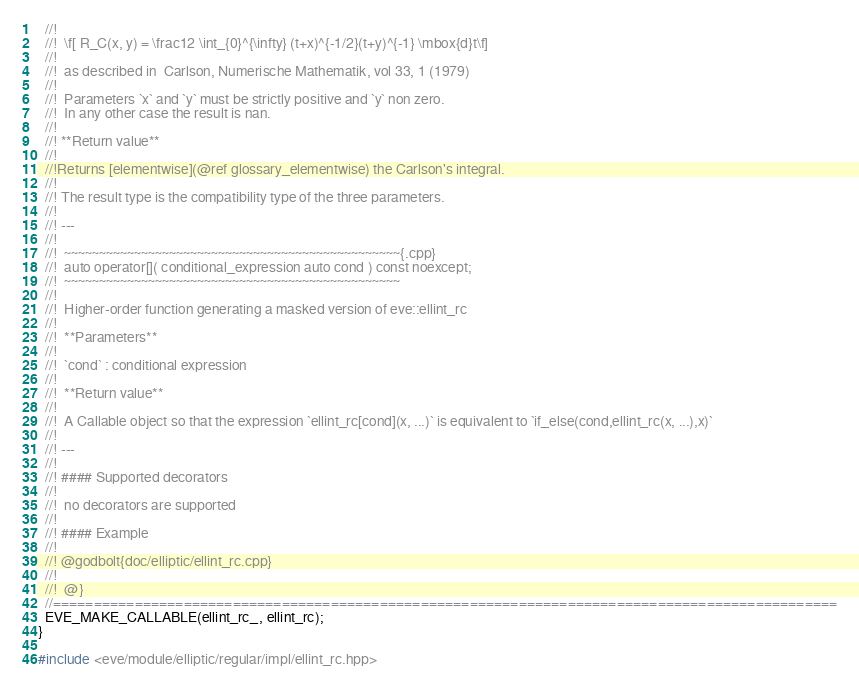<code> <loc_0><loc_0><loc_500><loc_500><_C++_>  //!
  //!  \f[ R_C(x, y) = \frac12 \int_{0}^{\infty} (t+x)^{-1/2}(t+y)^{-1} \mbox{d}t\f]
  //!
  //!  as described in  Carlson, Numerische Mathematik, vol 33, 1 (1979)
  //!
  //!  Parameters `x` and `y` must be strictly positive and `y` non zero.
  //!  In any other case the result is nan.
  //!
  //! **Return value**
  //!
  //!Returns [elementwise](@ref glossary_elementwise) the Carlson's integral.
  //!
  //! The result type is the compatibility type of the three parameters.
  //!
  //! ---
  //!
  //!  ~~~~~~~~~~~~~~~~~~~~~~~~~~~~~~~~~~~~~~~~~~~~~~~~{.cpp}
  //!  auto operator[]( conditional_expression auto cond ) const noexcept;
  //!  ~~~~~~~~~~~~~~~~~~~~~~~~~~~~~~~~~~~~~~~~~~~~~~~~
  //!
  //!  Higher-order function generating a masked version of eve::ellint_rc
  //!
  //!  **Parameters**
  //!
  //!  `cond` : conditional expression
  //!
  //!  **Return value**
  //!
  //!  A Callable object so that the expression `ellint_rc[cond](x, ...)` is equivalent to `if_else(cond,ellint_rc(x, ...),x)`
  //!
  //! ---
  //!
  //! #### Supported decorators
  //!
  //!  no decorators are supported
  //!
  //! #### Example
  //!
  //! @godbolt{doc/elliptic/ellint_rc.cpp}
  //!
  //!  @}
  //================================================================================================
  EVE_MAKE_CALLABLE(ellint_rc_, ellint_rc);
}

#include <eve/module/elliptic/regular/impl/ellint_rc.hpp>
</code> 